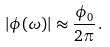Convert formula to latex. <formula><loc_0><loc_0><loc_500><loc_500>| \phi ( \omega ) | \approx \frac { \phi _ { 0 } } { 2 \pi } \, .</formula> 